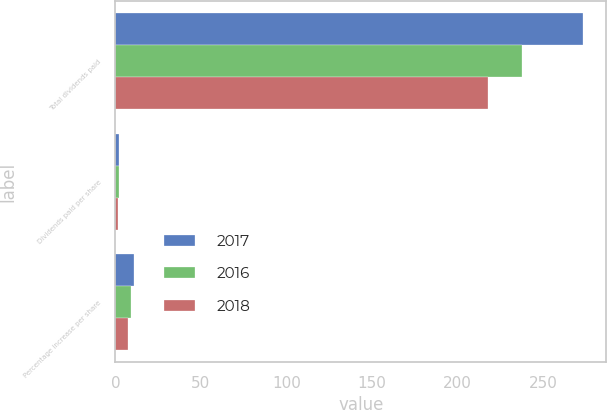Convert chart. <chart><loc_0><loc_0><loc_500><loc_500><stacked_bar_chart><ecel><fcel>Total dividends paid<fcel>Dividends paid per share<fcel>Percentage increase per share<nl><fcel>2017<fcel>273.4<fcel>2.08<fcel>10.6<nl><fcel>2016<fcel>237.6<fcel>1.88<fcel>9.3<nl><fcel>2018<fcel>217.8<fcel>1.72<fcel>7.5<nl></chart> 